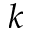Convert formula to latex. <formula><loc_0><loc_0><loc_500><loc_500>k</formula> 